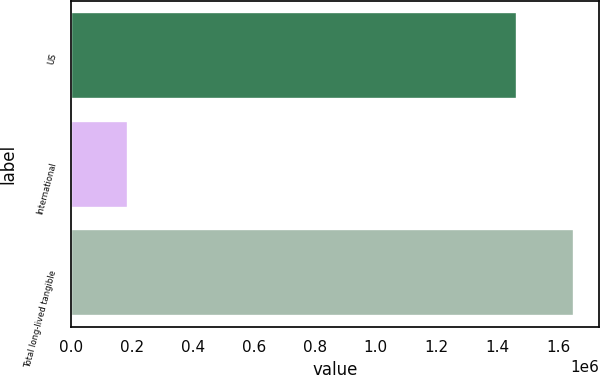Convert chart. <chart><loc_0><loc_0><loc_500><loc_500><bar_chart><fcel>US<fcel>International<fcel>Total long-lived tangible<nl><fcel>1.46523e+06<fcel>186251<fcel>1.65148e+06<nl></chart> 